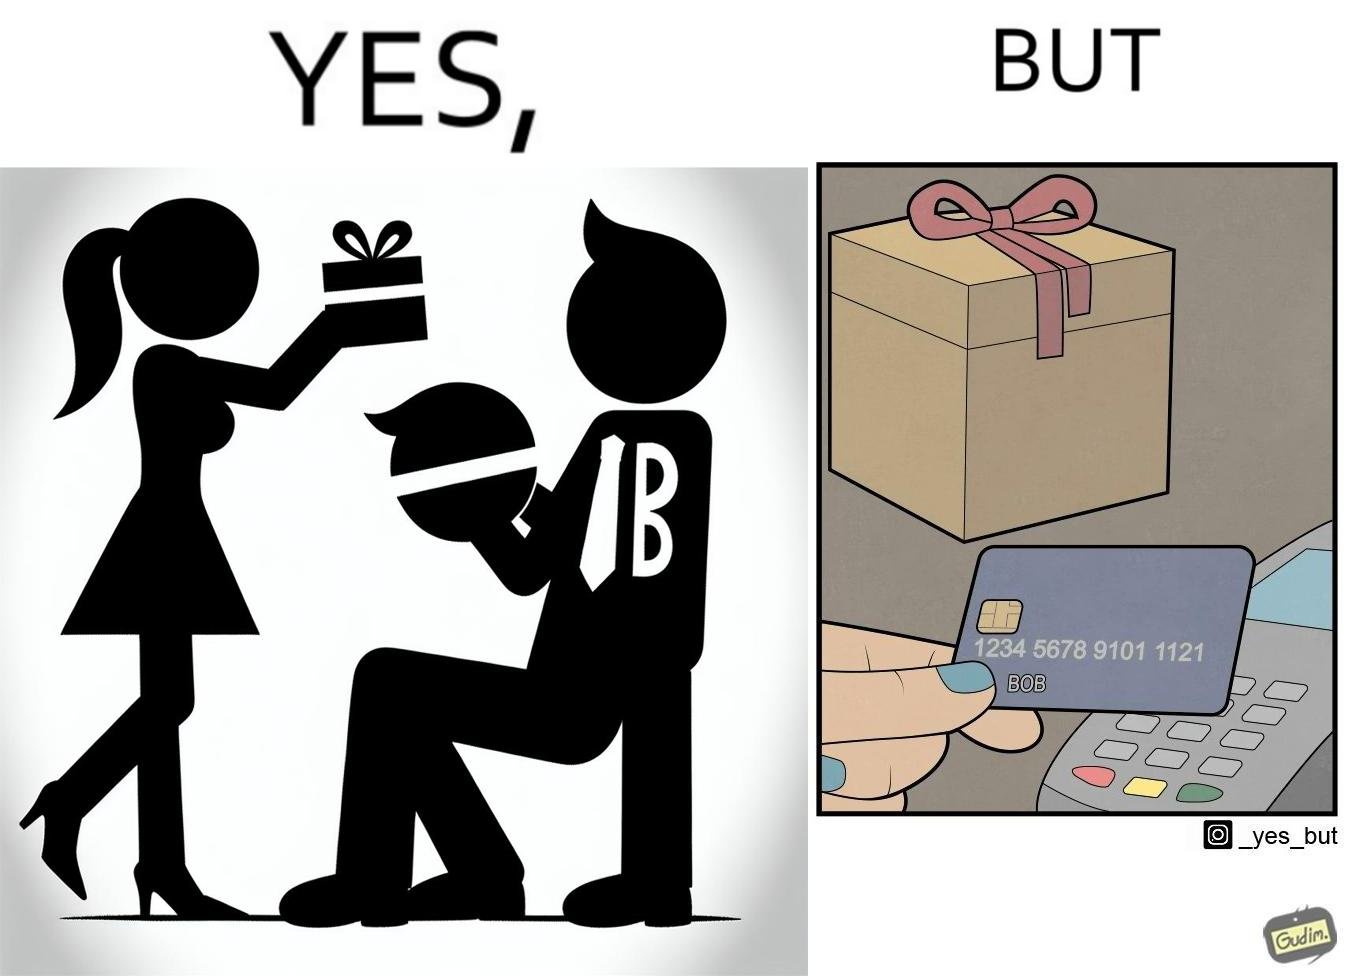Describe the satirical element in this image. The image is ironical, as a woman is gifting something to a person named Bob, while using Bob's card itself to purchase the gift. 